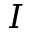<formula> <loc_0><loc_0><loc_500><loc_500>I</formula> 